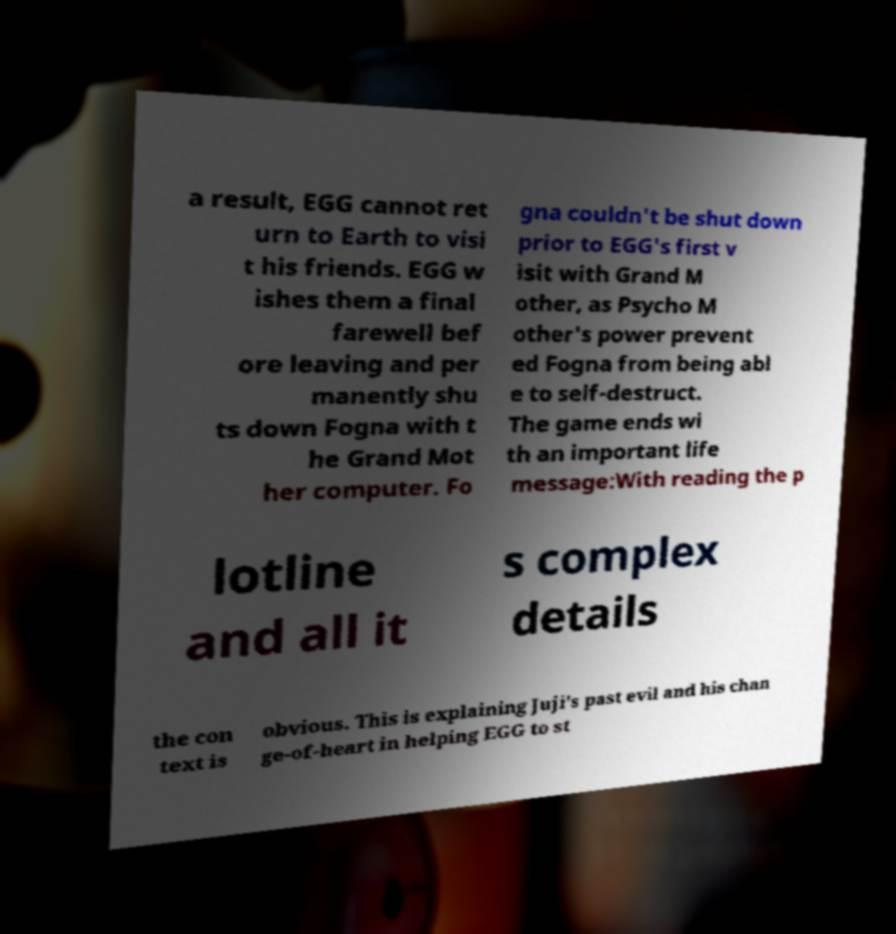Please identify and transcribe the text found in this image. a result, EGG cannot ret urn to Earth to visi t his friends. EGG w ishes them a final farewell bef ore leaving and per manently shu ts down Fogna with t he Grand Mot her computer. Fo gna couldn't be shut down prior to EGG's first v isit with Grand M other, as Psycho M other's power prevent ed Fogna from being abl e to self-destruct. The game ends wi th an important life message:With reading the p lotline and all it s complex details the con text is obvious. This is explaining Juji's past evil and his chan ge-of-heart in helping EGG to st 